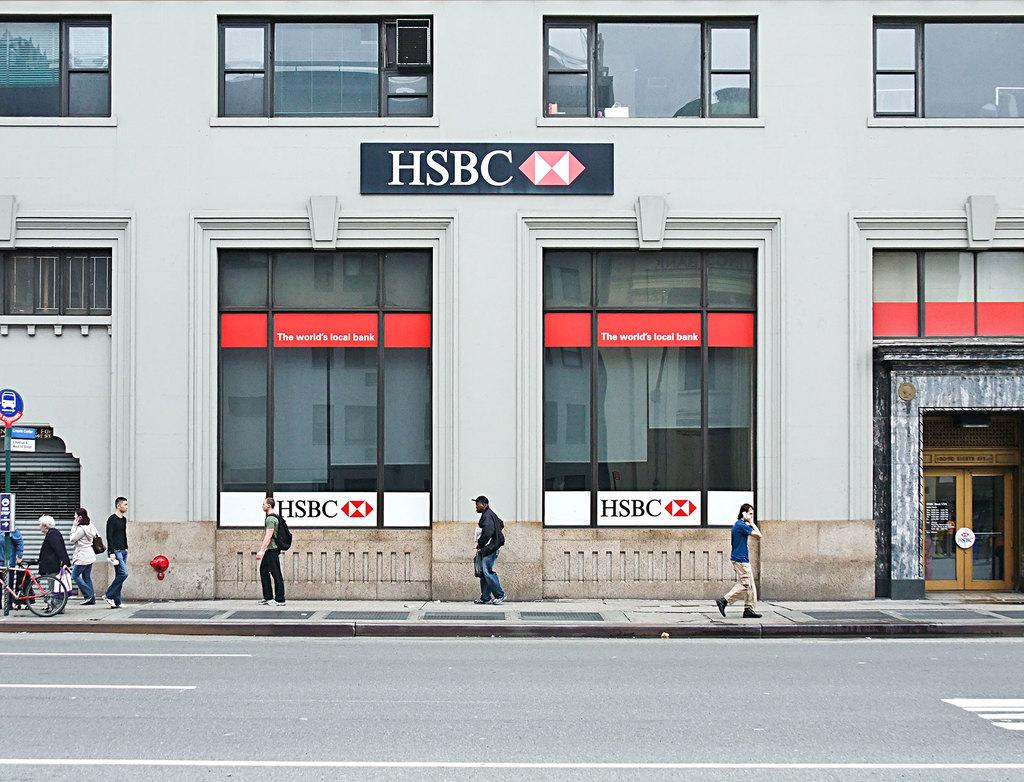<image>
Relay a brief, clear account of the picture shown. People are walking on the streets in front of an HSBC building. 